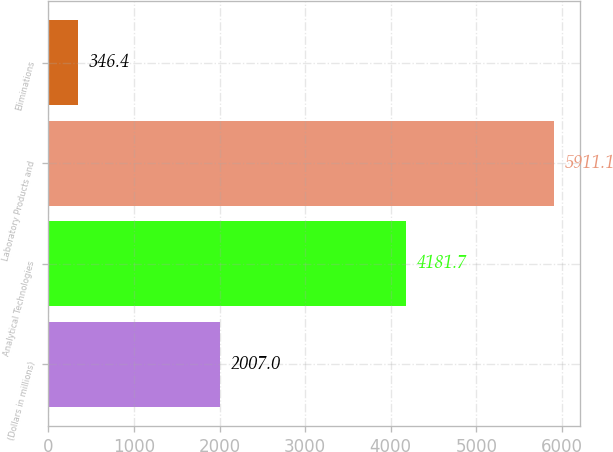Convert chart to OTSL. <chart><loc_0><loc_0><loc_500><loc_500><bar_chart><fcel>(Dollars in millions)<fcel>Analytical Technologies<fcel>Laboratory Products and<fcel>Eliminations<nl><fcel>2007<fcel>4181.7<fcel>5911.1<fcel>346.4<nl></chart> 